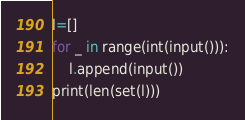<code> <loc_0><loc_0><loc_500><loc_500><_Python_>l=[]
for _ in range(int(input())):
    l.append(input())
print(len(set(l)))</code> 